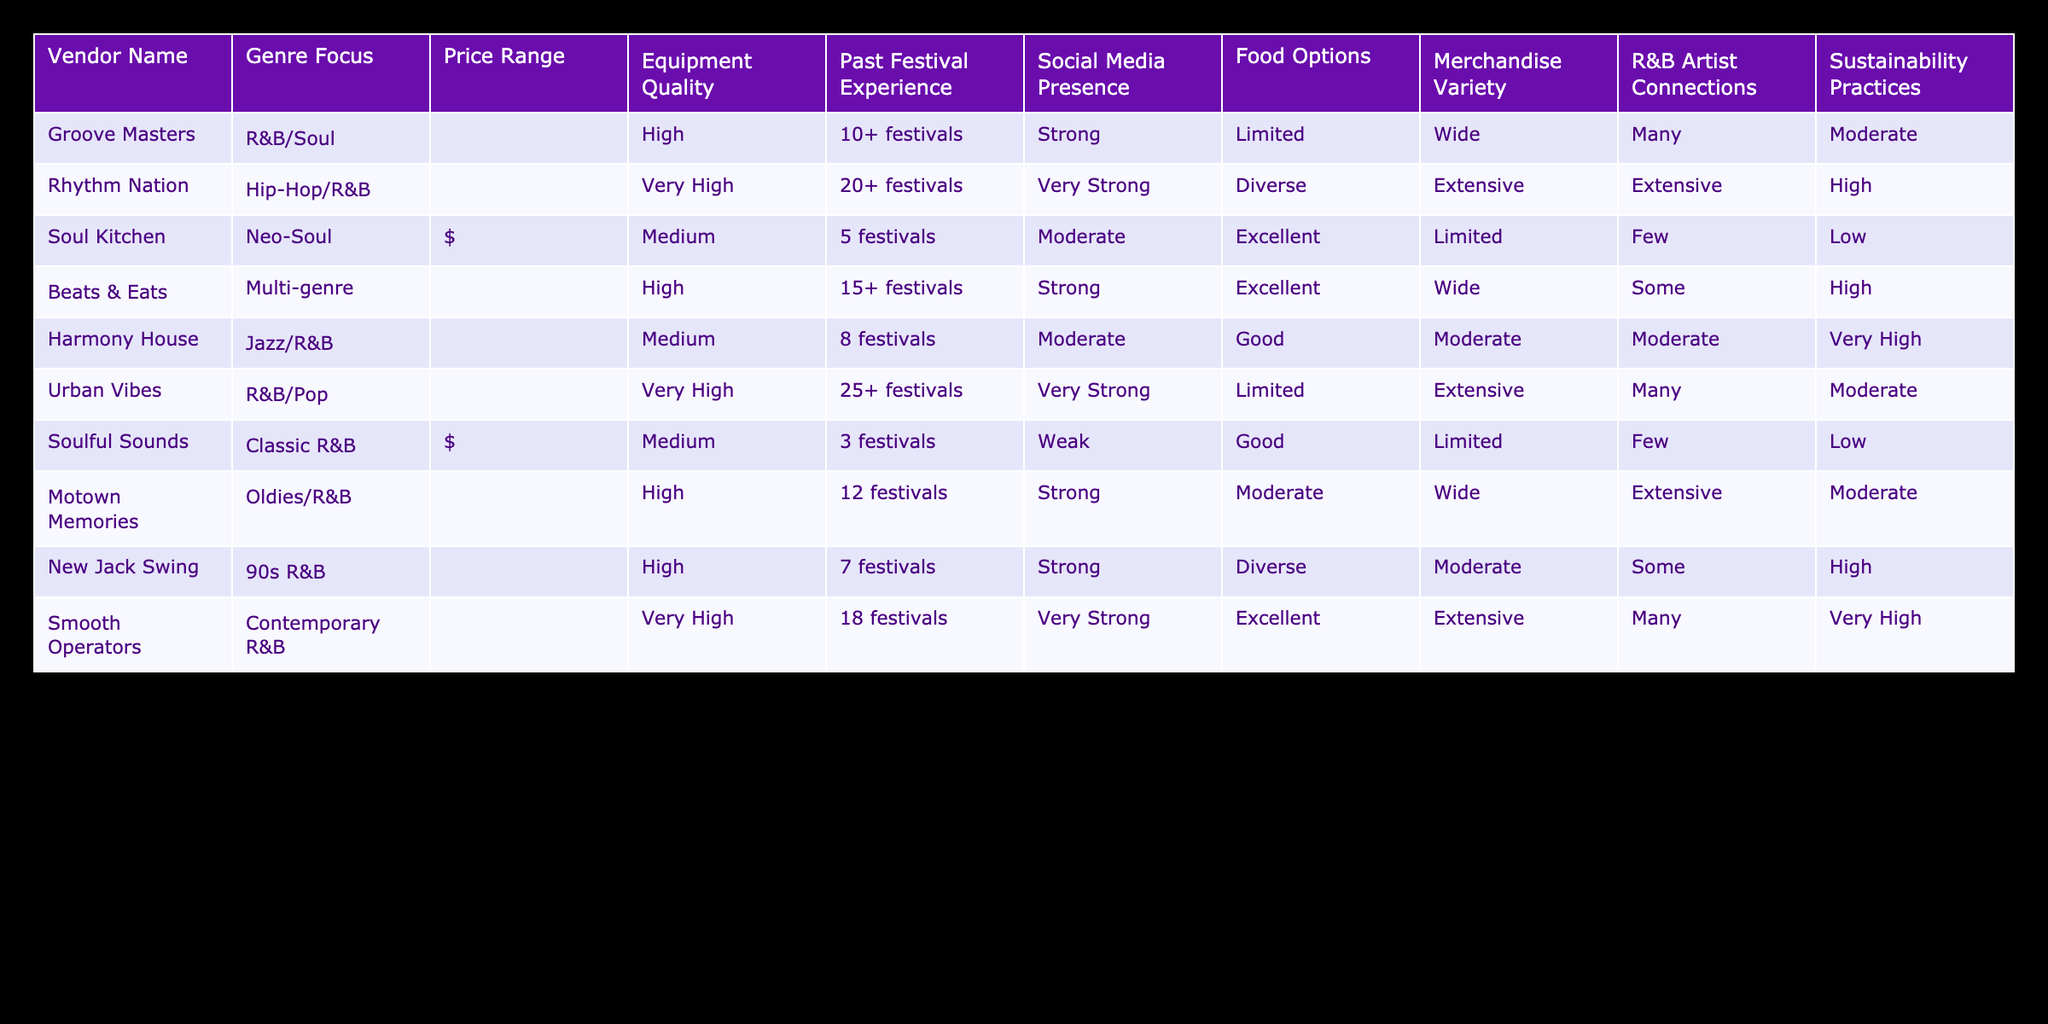What is the price range for Rhythm Nation? Rhythm Nation has a price range of $$$, which can be found in the price range column corresponding to the vendor's name.
Answer: $$$ How many festivals has Groove Masters participated in? Groove Masters has participated in 10+ festivals, which can be directly referenced from the past festival experience column of the vendor.
Answer: 10+ festivals Which vendor has the highest social media presence? Urban Vibes and Rhythm Nation both have a very strong social media presence, indicated in the social media presence column as "Very Strong."
Answer: Urban Vibes and Rhythm Nation Is there a vendor with limited food options that also has a high merchandise variety? Yes, Groove Masters is the vendor with limited food options and a wide merchandise variety, as indicated in the food options and merchandise variety columns.
Answer: Yes What is the average equipment quality rating of the vendors that focus on R&B? The equipment quality ratings for the R&B-focused vendors are High (Groove Masters), Very High (Urban Vibes), Medium (Harmony House), and Medium (Soulful Sounds), averaging to (3+4+2+2)/4 = 2.75 or Medium.
Answer: Medium How many vendors have extensive merchandise variety? To find this, we can count the number of vendors that have "Extensive" in the merchandise variety column. Only Rhythm Nation, Urban Vibes, Beats & Eats, and Smooth Operators fit this category, resulting in a total of 4 vendors.
Answer: 4 vendors Are there any vendors that practice sustainability at a high level and focus on R&B? Yes, both Rhythm Nation and Smooth Operators have high sustainability practices while focusing on R&B genres.
Answer: Yes Which vendor with a medium price range has the most past festival experience? Beat & Eats and Harmony House are tied for having the most past festival experience of 15+ and 8 festivals respectively, although Beat & Eats is the one that has the upper hand in price range as it focuses on multiple genres.
Answer: Beats & Eats What percentage of vendors offer limited food options? From the table, Groove Masters, Urban Vibes, and Soulful Sounds offer limited food options. Since there are 10 vendors, this means that 3 out of 10 vendors, or 30%, offer limited food options.
Answer: 30% 